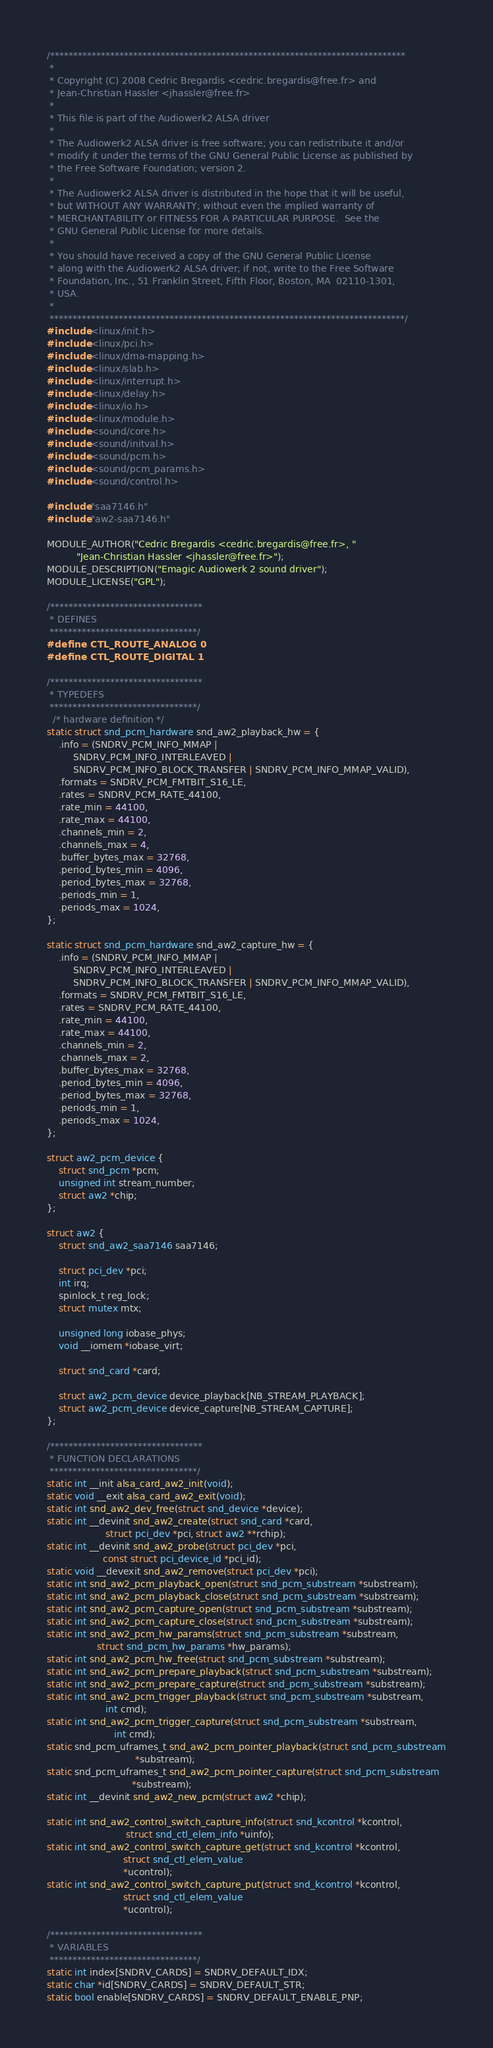<code> <loc_0><loc_0><loc_500><loc_500><_C_>/*****************************************************************************
 *
 * Copyright (C) 2008 Cedric Bregardis <cedric.bregardis@free.fr> and
 * Jean-Christian Hassler <jhassler@free.fr>
 *
 * This file is part of the Audiowerk2 ALSA driver
 *
 * The Audiowerk2 ALSA driver is free software; you can redistribute it and/or
 * modify it under the terms of the GNU General Public License as published by
 * the Free Software Foundation; version 2.
 *
 * The Audiowerk2 ALSA driver is distributed in the hope that it will be useful,
 * but WITHOUT ANY WARRANTY; without even the implied warranty of
 * MERCHANTABILITY or FITNESS FOR A PARTICULAR PURPOSE.  See the
 * GNU General Public License for more details.
 *
 * You should have received a copy of the GNU General Public License
 * along with the Audiowerk2 ALSA driver; if not, write to the Free Software
 * Foundation, Inc., 51 Franklin Street, Fifth Floor, Boston, MA  02110-1301,
 * USA.
 *
 *****************************************************************************/
#include <linux/init.h>
#include <linux/pci.h>
#include <linux/dma-mapping.h>
#include <linux/slab.h>
#include <linux/interrupt.h>
#include <linux/delay.h>
#include <linux/io.h>
#include <linux/module.h>
#include <sound/core.h>
#include <sound/initval.h>
#include <sound/pcm.h>
#include <sound/pcm_params.h>
#include <sound/control.h>

#include "saa7146.h"
#include "aw2-saa7146.h"

MODULE_AUTHOR("Cedric Bregardis <cedric.bregardis@free.fr>, "
	      "Jean-Christian Hassler <jhassler@free.fr>");
MODULE_DESCRIPTION("Emagic Audiowerk 2 sound driver");
MODULE_LICENSE("GPL");

/*********************************
 * DEFINES
 ********************************/
#define CTL_ROUTE_ANALOG 0
#define CTL_ROUTE_DIGITAL 1

/*********************************
 * TYPEDEFS
 ********************************/
  /* hardware definition */
static struct snd_pcm_hardware snd_aw2_playback_hw = {
	.info = (SNDRV_PCM_INFO_MMAP |
		 SNDRV_PCM_INFO_INTERLEAVED |
		 SNDRV_PCM_INFO_BLOCK_TRANSFER | SNDRV_PCM_INFO_MMAP_VALID),
	.formats = SNDRV_PCM_FMTBIT_S16_LE,
	.rates = SNDRV_PCM_RATE_44100,
	.rate_min = 44100,
	.rate_max = 44100,
	.channels_min = 2,
	.channels_max = 4,
	.buffer_bytes_max = 32768,
	.period_bytes_min = 4096,
	.period_bytes_max = 32768,
	.periods_min = 1,
	.periods_max = 1024,
};

static struct snd_pcm_hardware snd_aw2_capture_hw = {
	.info = (SNDRV_PCM_INFO_MMAP |
		 SNDRV_PCM_INFO_INTERLEAVED |
		 SNDRV_PCM_INFO_BLOCK_TRANSFER | SNDRV_PCM_INFO_MMAP_VALID),
	.formats = SNDRV_PCM_FMTBIT_S16_LE,
	.rates = SNDRV_PCM_RATE_44100,
	.rate_min = 44100,
	.rate_max = 44100,
	.channels_min = 2,
	.channels_max = 2,
	.buffer_bytes_max = 32768,
	.period_bytes_min = 4096,
	.period_bytes_max = 32768,
	.periods_min = 1,
	.periods_max = 1024,
};

struct aw2_pcm_device {
	struct snd_pcm *pcm;
	unsigned int stream_number;
	struct aw2 *chip;
};

struct aw2 {
	struct snd_aw2_saa7146 saa7146;

	struct pci_dev *pci;
	int irq;
	spinlock_t reg_lock;
	struct mutex mtx;

	unsigned long iobase_phys;
	void __iomem *iobase_virt;

	struct snd_card *card;

	struct aw2_pcm_device device_playback[NB_STREAM_PLAYBACK];
	struct aw2_pcm_device device_capture[NB_STREAM_CAPTURE];
};

/*********************************
 * FUNCTION DECLARATIONS
 ********************************/
static int __init alsa_card_aw2_init(void);
static void __exit alsa_card_aw2_exit(void);
static int snd_aw2_dev_free(struct snd_device *device);
static int __devinit snd_aw2_create(struct snd_card *card,
				    struct pci_dev *pci, struct aw2 **rchip);
static int __devinit snd_aw2_probe(struct pci_dev *pci,
				   const struct pci_device_id *pci_id);
static void __devexit snd_aw2_remove(struct pci_dev *pci);
static int snd_aw2_pcm_playback_open(struct snd_pcm_substream *substream);
static int snd_aw2_pcm_playback_close(struct snd_pcm_substream *substream);
static int snd_aw2_pcm_capture_open(struct snd_pcm_substream *substream);
static int snd_aw2_pcm_capture_close(struct snd_pcm_substream *substream);
static int snd_aw2_pcm_hw_params(struct snd_pcm_substream *substream,
				 struct snd_pcm_hw_params *hw_params);
static int snd_aw2_pcm_hw_free(struct snd_pcm_substream *substream);
static int snd_aw2_pcm_prepare_playback(struct snd_pcm_substream *substream);
static int snd_aw2_pcm_prepare_capture(struct snd_pcm_substream *substream);
static int snd_aw2_pcm_trigger_playback(struct snd_pcm_substream *substream,
					int cmd);
static int snd_aw2_pcm_trigger_capture(struct snd_pcm_substream *substream,
				       int cmd);
static snd_pcm_uframes_t snd_aw2_pcm_pointer_playback(struct snd_pcm_substream
						      *substream);
static snd_pcm_uframes_t snd_aw2_pcm_pointer_capture(struct snd_pcm_substream
						     *substream);
static int __devinit snd_aw2_new_pcm(struct aw2 *chip);

static int snd_aw2_control_switch_capture_info(struct snd_kcontrol *kcontrol,
					       struct snd_ctl_elem_info *uinfo);
static int snd_aw2_control_switch_capture_get(struct snd_kcontrol *kcontrol,
					      struct snd_ctl_elem_value
					      *ucontrol);
static int snd_aw2_control_switch_capture_put(struct snd_kcontrol *kcontrol,
					      struct snd_ctl_elem_value
					      *ucontrol);

/*********************************
 * VARIABLES
 ********************************/
static int index[SNDRV_CARDS] = SNDRV_DEFAULT_IDX;
static char *id[SNDRV_CARDS] = SNDRV_DEFAULT_STR;
static bool enable[SNDRV_CARDS] = SNDRV_DEFAULT_ENABLE_PNP;
</code> 